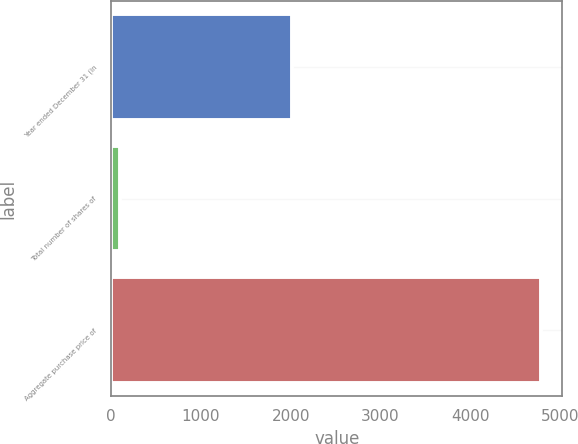Convert chart. <chart><loc_0><loc_0><loc_500><loc_500><bar_chart><fcel>Year ended December 31 (in<fcel>Total number of shares of<fcel>Aggregate purchase price of<nl><fcel>2013<fcel>96.1<fcel>4789<nl></chart> 